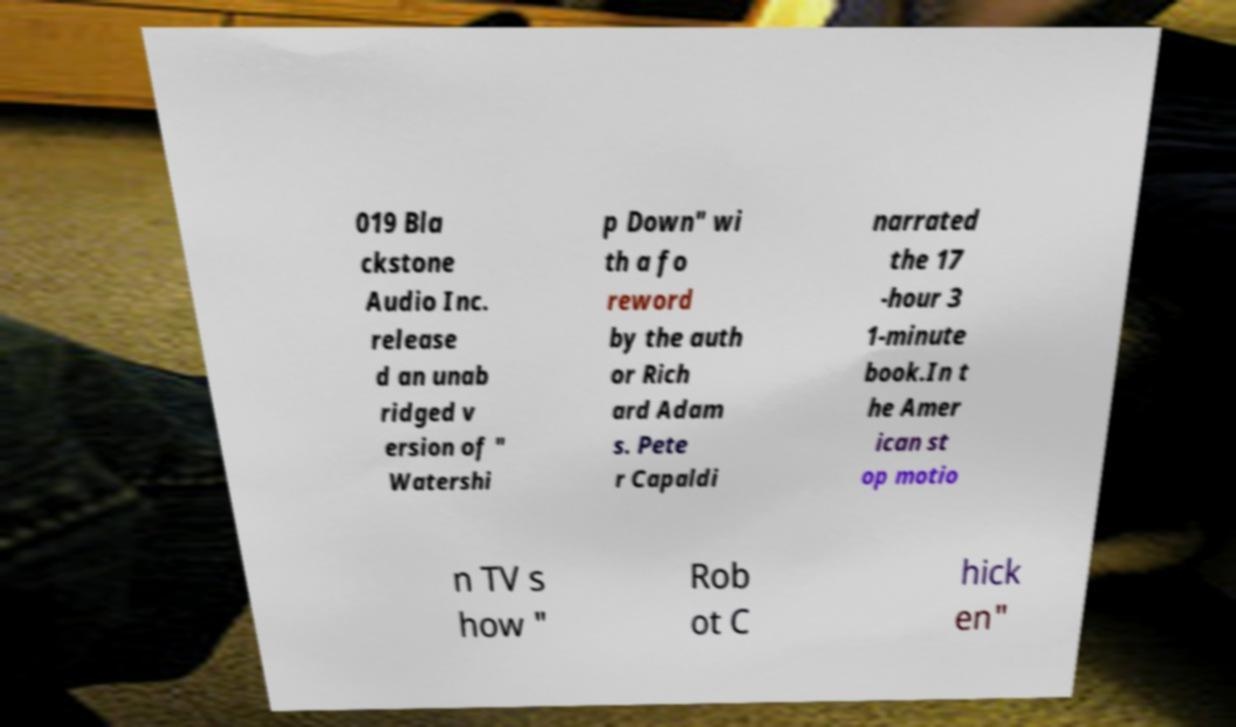Could you assist in decoding the text presented in this image and type it out clearly? 019 Bla ckstone Audio Inc. release d an unab ridged v ersion of " Watershi p Down" wi th a fo reword by the auth or Rich ard Adam s. Pete r Capaldi narrated the 17 -hour 3 1-minute book.In t he Amer ican st op motio n TV s how " Rob ot C hick en" 